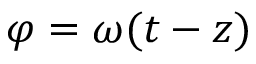<formula> <loc_0><loc_0><loc_500><loc_500>\varphi = \omega ( t - z )</formula> 